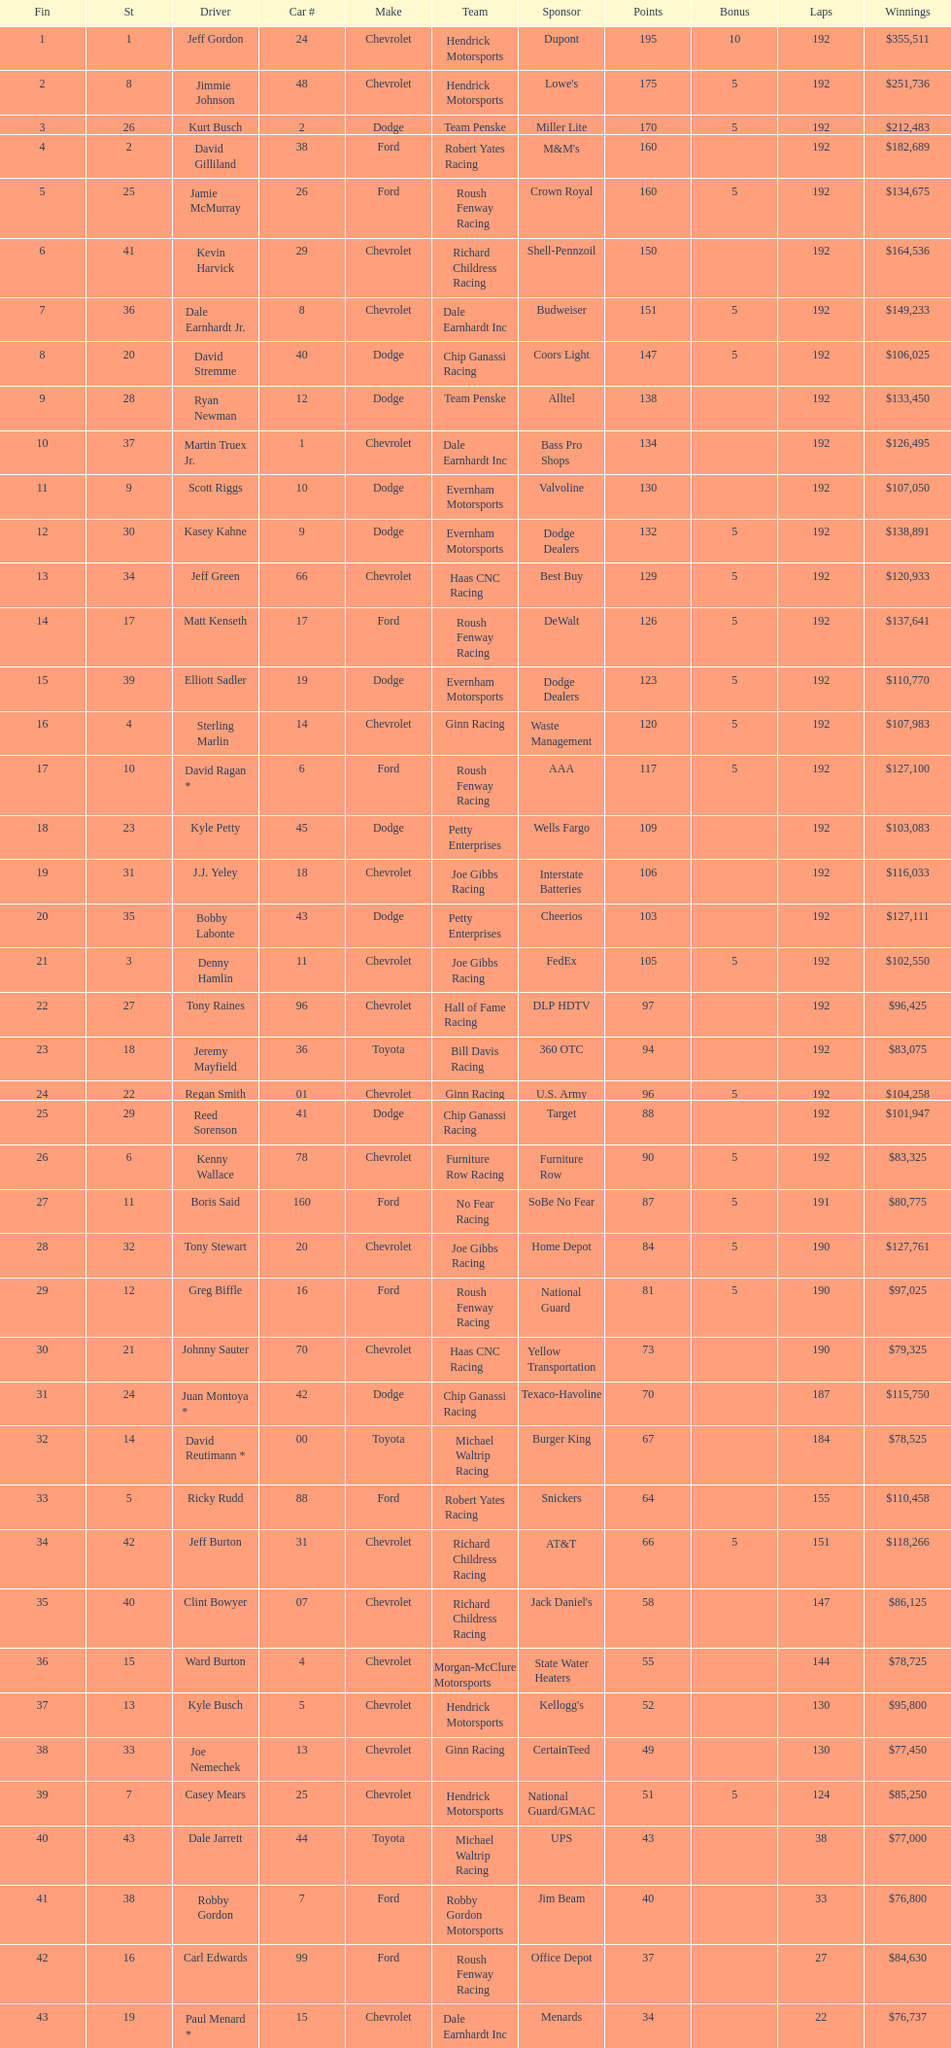What make did kurt busch drive? Dodge. 